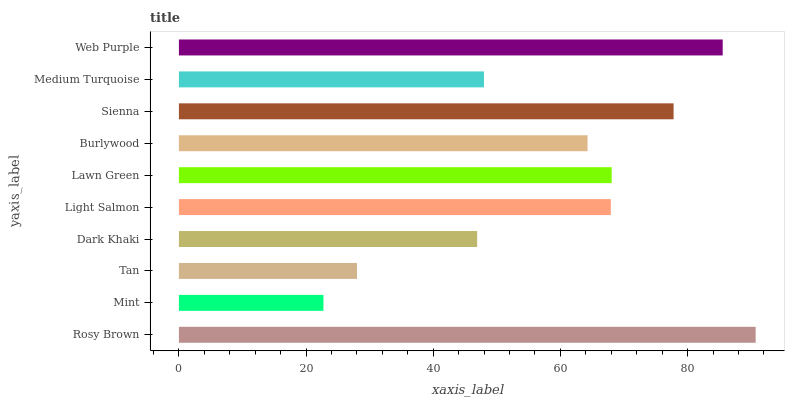Is Mint the minimum?
Answer yes or no. Yes. Is Rosy Brown the maximum?
Answer yes or no. Yes. Is Tan the minimum?
Answer yes or no. No. Is Tan the maximum?
Answer yes or no. No. Is Tan greater than Mint?
Answer yes or no. Yes. Is Mint less than Tan?
Answer yes or no. Yes. Is Mint greater than Tan?
Answer yes or no. No. Is Tan less than Mint?
Answer yes or no. No. Is Light Salmon the high median?
Answer yes or no. Yes. Is Burlywood the low median?
Answer yes or no. Yes. Is Tan the high median?
Answer yes or no. No. Is Sienna the low median?
Answer yes or no. No. 